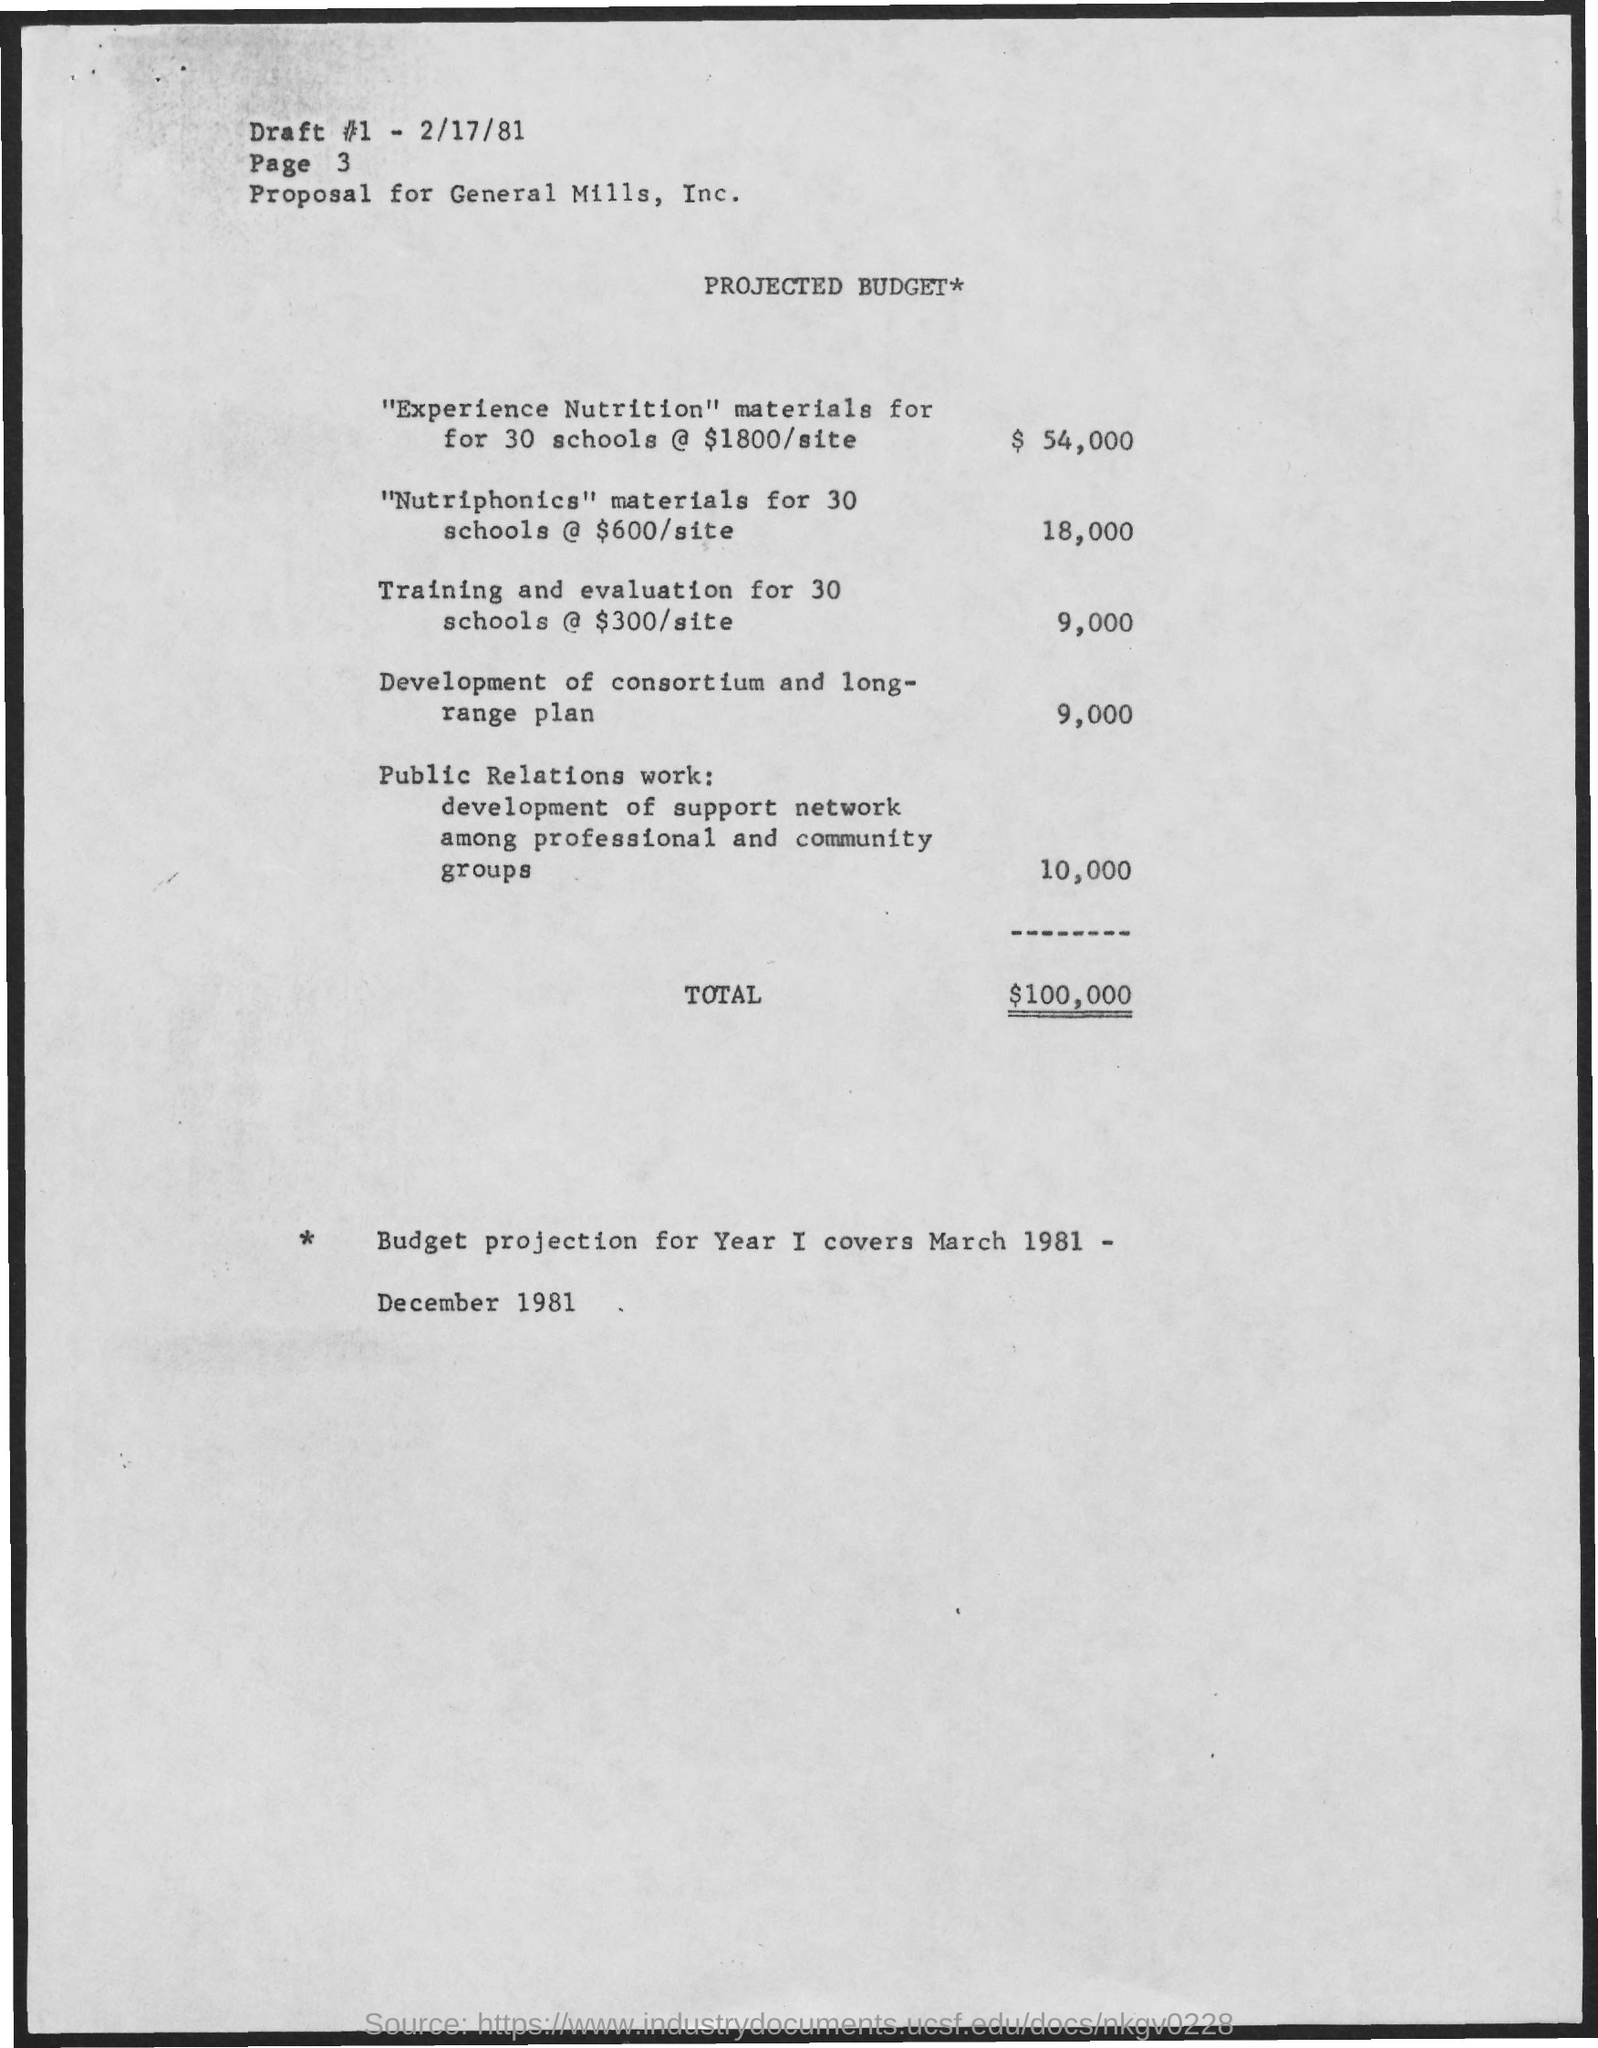Specify some key components in this picture. This is a draft dated February 17, 1981. The training and evaluation for 30 schools, with each site costing $300, totals $9,000. The total cost for supplying "nutriphonics" materials to 30 schools is $18,000. We will provide "experience nutrition" materials to 30 schools at a cost of $1800/site, resulting in a total cost of $54,000. The document in question is titled "PROJECTED BUDGET. 